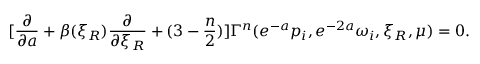<formula> <loc_0><loc_0><loc_500><loc_500>[ { \frac { \partial } { \partial a } } + \beta ( \xi _ { R } ) { \frac { \partial } { \partial \xi _ { R } } } + ( 3 - { \frac { n } { 2 } } ) ] \Gamma ^ { n } ( e ^ { - a } p _ { i } , e ^ { - 2 a } \omega _ { i } , \xi _ { R } , \mu ) = 0 .</formula> 